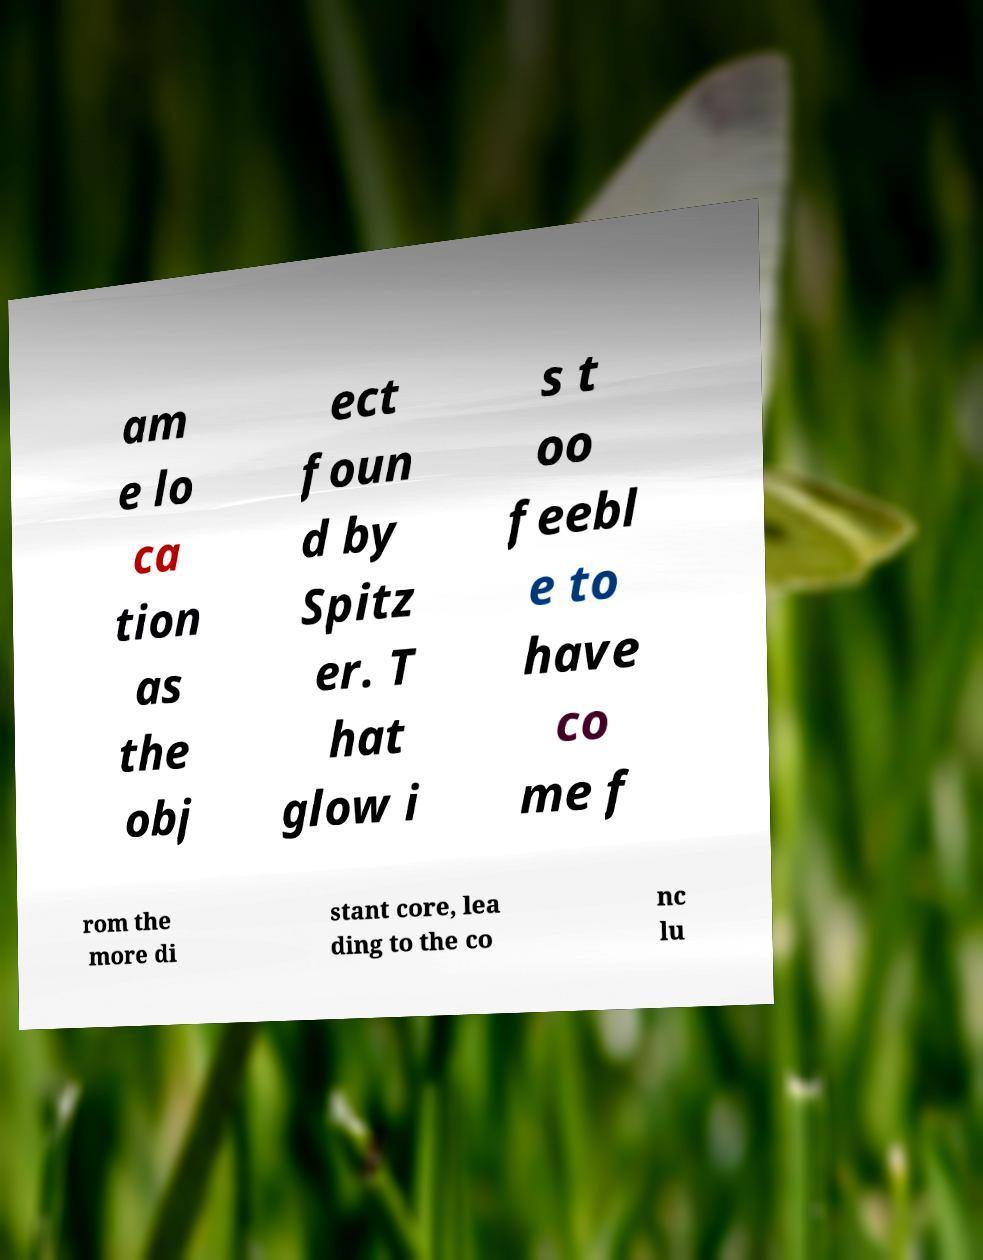Can you accurately transcribe the text from the provided image for me? am e lo ca tion as the obj ect foun d by Spitz er. T hat glow i s t oo feebl e to have co me f rom the more di stant core, lea ding to the co nc lu 